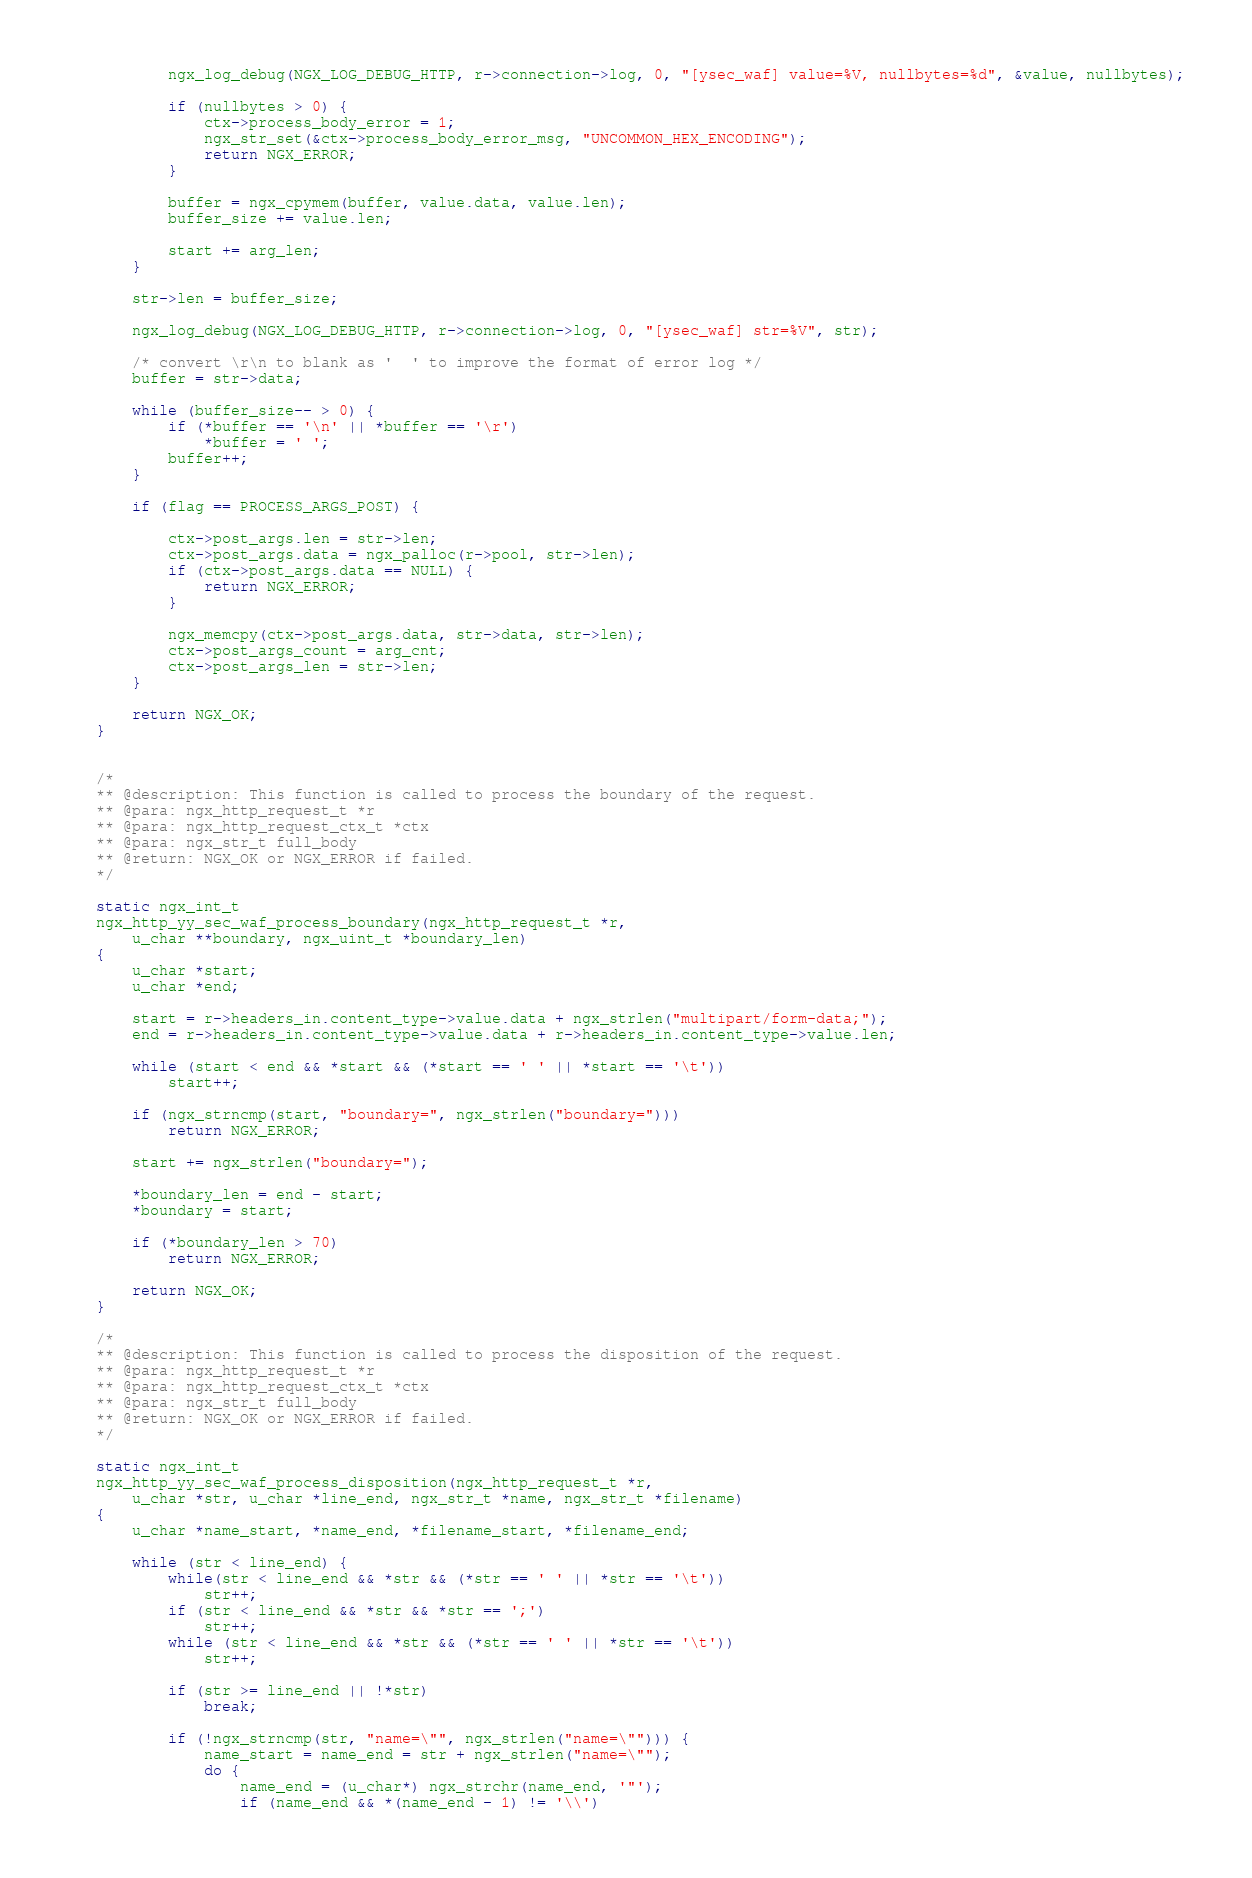<code> <loc_0><loc_0><loc_500><loc_500><_C_>
        ngx_log_debug(NGX_LOG_DEBUG_HTTP, r->connection->log, 0, "[ysec_waf] value=%V, nullbytes=%d", &value, nullbytes);

        if (nullbytes > 0) {
            ctx->process_body_error = 1;
            ngx_str_set(&ctx->process_body_error_msg, "UNCOMMON_HEX_ENCODING");
            return NGX_ERROR;
        }

        buffer = ngx_cpymem(buffer, value.data, value.len);
        buffer_size += value.len;

        start += arg_len;
    }

    str->len = buffer_size;

    ngx_log_debug(NGX_LOG_DEBUG_HTTP, r->connection->log, 0, "[ysec_waf] str=%V", str);

    /* convert \r\n to blank as '  ' to improve the format of error log */
    buffer = str->data;

    while (buffer_size-- > 0) {
        if (*buffer == '\n' || *buffer == '\r')
            *buffer = ' ';
        buffer++;
    }

    if (flag == PROCESS_ARGS_POST) {

        ctx->post_args.len = str->len;
        ctx->post_args.data = ngx_palloc(r->pool, str->len);
        if (ctx->post_args.data == NULL) {
            return NGX_ERROR;
        }
    
        ngx_memcpy(ctx->post_args.data, str->data, str->len);
        ctx->post_args_count = arg_cnt;
        ctx->post_args_len = str->len;
    }
	
    return NGX_OK;
}


/*
** @description: This function is called to process the boundary of the request.
** @para: ngx_http_request_t *r
** @para: ngx_http_request_ctx_t *ctx
** @para: ngx_str_t full_body
** @return: NGX_OK or NGX_ERROR if failed.
*/

static ngx_int_t
ngx_http_yy_sec_waf_process_boundary(ngx_http_request_t *r,
    u_char **boundary, ngx_uint_t *boundary_len)
{
    u_char *start;
    u_char *end;

    start = r->headers_in.content_type->value.data + ngx_strlen("multipart/form-data;");
    end = r->headers_in.content_type->value.data + r->headers_in.content_type->value.len;

    while (start < end && *start && (*start == ' ' || *start == '\t'))
        start++;

    if (ngx_strncmp(start, "boundary=", ngx_strlen("boundary=")))
        return NGX_ERROR;

    start += ngx_strlen("boundary=");

    *boundary_len = end - start;
    *boundary = start;

    if (*boundary_len > 70)
        return NGX_ERROR;

    return NGX_OK;
}

/*
** @description: This function is called to process the disposition of the request.
** @para: ngx_http_request_t *r
** @para: ngx_http_request_ctx_t *ctx
** @para: ngx_str_t full_body
** @return: NGX_OK or NGX_ERROR if failed.
*/

static ngx_int_t
ngx_http_yy_sec_waf_process_disposition(ngx_http_request_t *r,
    u_char *str, u_char *line_end, ngx_str_t *name, ngx_str_t *filename)
{
    u_char *name_start, *name_end, *filename_start, *filename_end;

    while (str < line_end) {
        while(str < line_end && *str && (*str == ' ' || *str == '\t'))
            str++;
        if (str < line_end && *str && *str == ';')
            str++;
        while (str < line_end && *str && (*str == ' ' || *str == '\t'))
            str++;

        if (str >= line_end || !*str)
            break;

        if (!ngx_strncmp(str, "name=\"", ngx_strlen("name=\""))) {
            name_start = name_end = str + ngx_strlen("name=\"");
            do {
                name_end = (u_char*) ngx_strchr(name_end, '"');
                if (name_end && *(name_end - 1) != '\\')</code> 